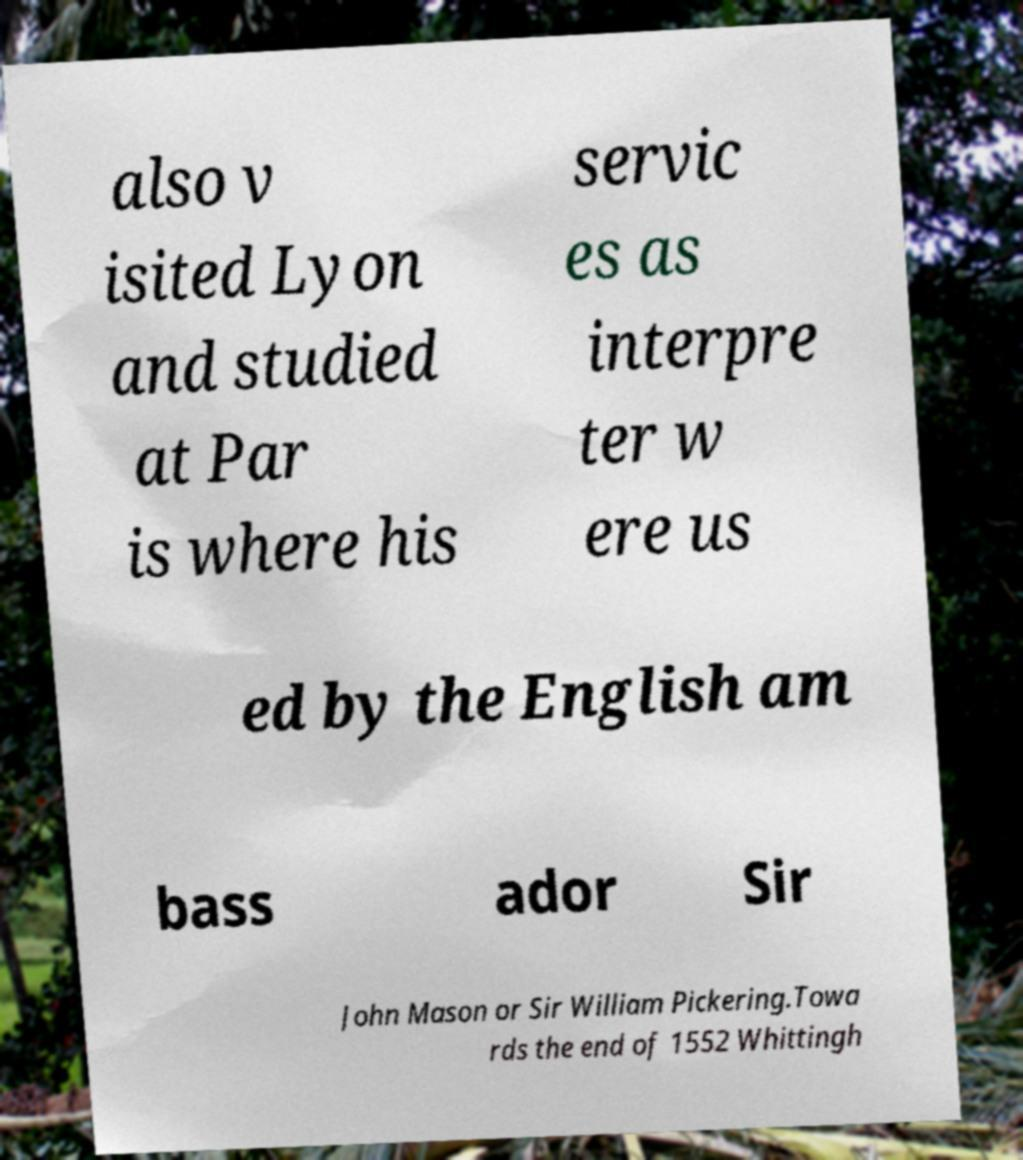What messages or text are displayed in this image? I need them in a readable, typed format. also v isited Lyon and studied at Par is where his servic es as interpre ter w ere us ed by the English am bass ador Sir John Mason or Sir William Pickering.Towa rds the end of 1552 Whittingh 